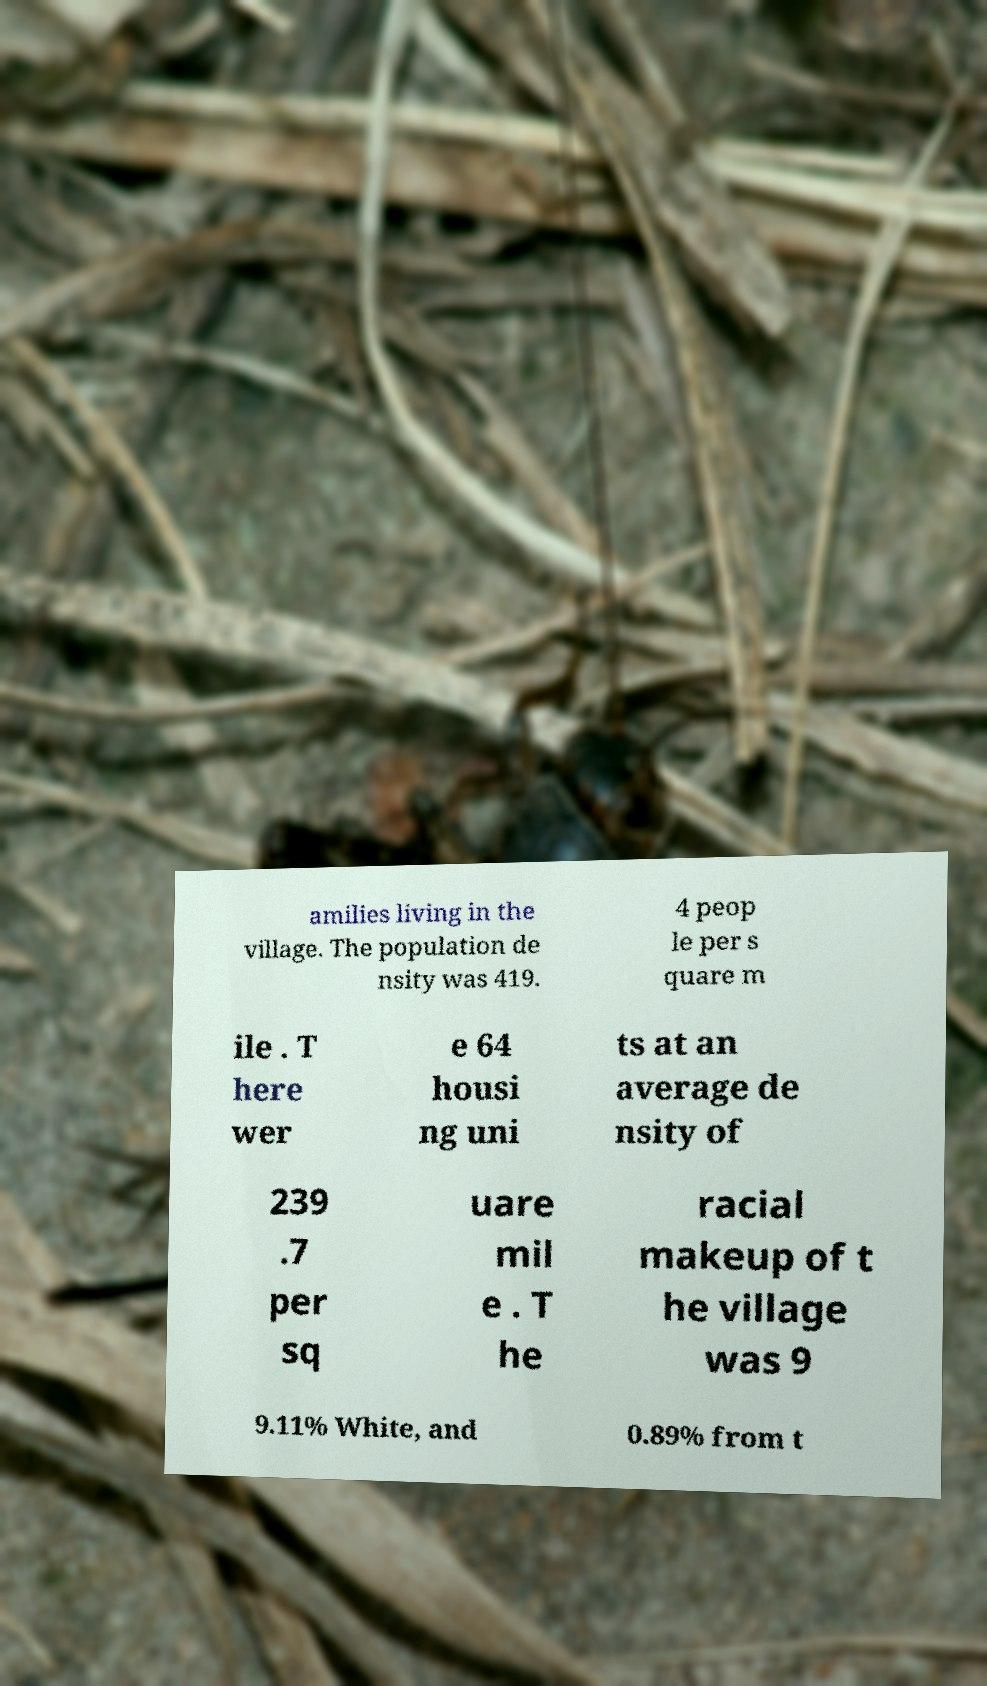Could you assist in decoding the text presented in this image and type it out clearly? amilies living in the village. The population de nsity was 419. 4 peop le per s quare m ile . T here wer e 64 housi ng uni ts at an average de nsity of 239 .7 per sq uare mil e . T he racial makeup of t he village was 9 9.11% White, and 0.89% from t 